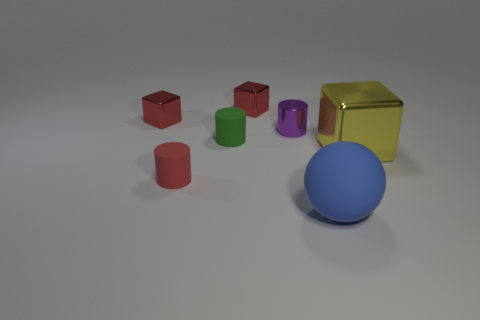Is there anything else that is the same shape as the blue thing?
Provide a succinct answer. No. Do the red cylinder and the yellow metal cube have the same size?
Offer a terse response. No. What number of other things are there of the same size as the red cylinder?
Offer a very short reply. 4. How many things are either big things behind the large matte ball or small metal cubes to the left of the green matte object?
Provide a succinct answer. 2. There is a green thing that is the same size as the red cylinder; what shape is it?
Provide a short and direct response. Cylinder. What is the size of the cylinder that is the same material as the green thing?
Your answer should be very brief. Small. Do the tiny purple shiny thing and the small red rubber object have the same shape?
Your answer should be very brief. Yes. What is the color of the thing that is the same size as the yellow shiny cube?
Your response must be concise. Blue. What size is the green thing that is the same shape as the purple shiny object?
Ensure brevity in your answer.  Small. What is the shape of the tiny rubber object that is to the left of the small green object?
Keep it short and to the point. Cylinder. 